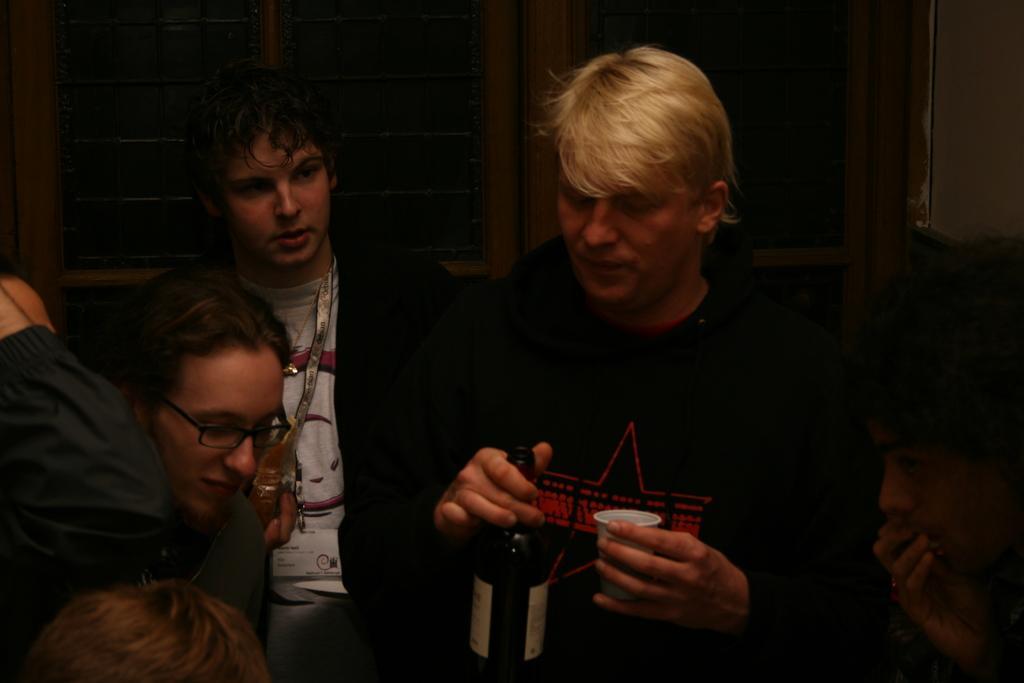Please provide a concise description of this image. In this image we can see few people. One person is holding a bottle and cup. Another person is wearing specs. In the back there are windows. 